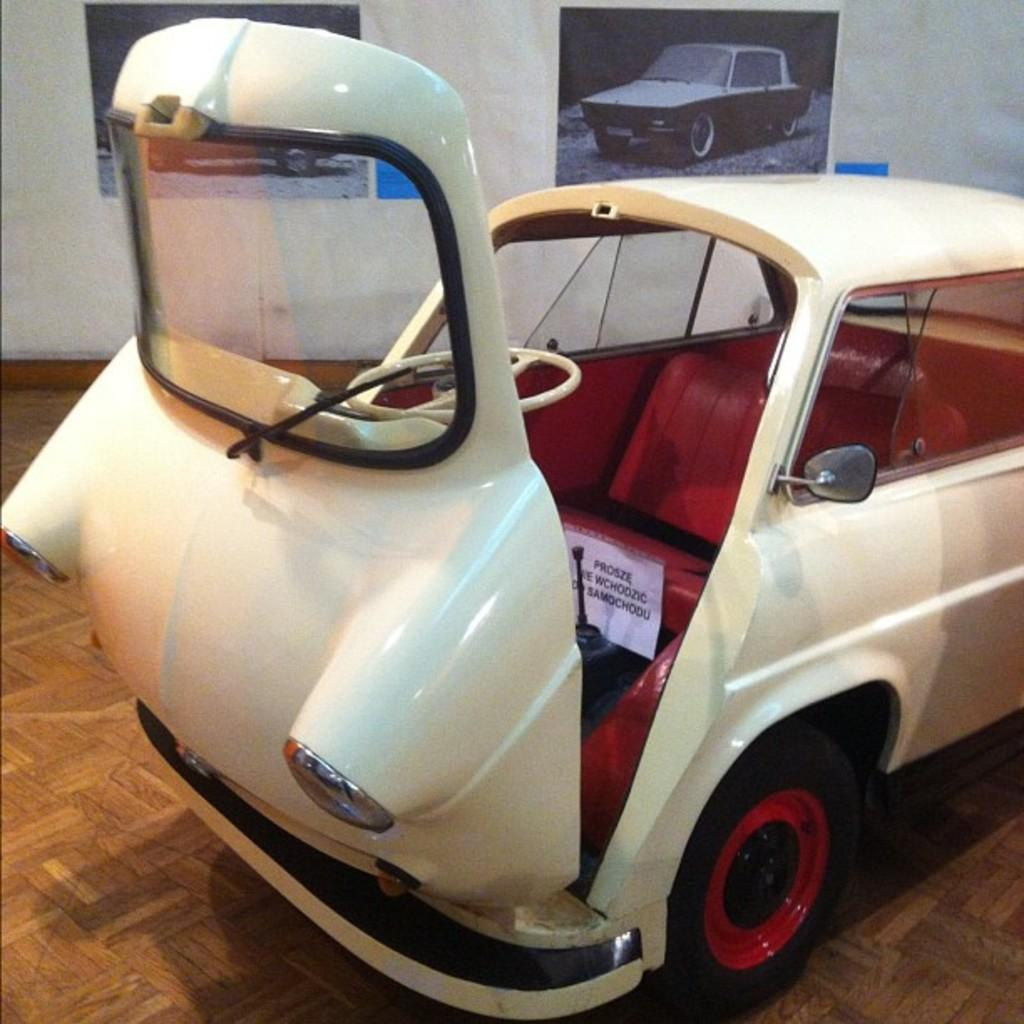What type of vehicle is in the image? There is a white car in the image. What else can be seen on the walls in the image? There are posters with text and images in the image. What is the background of the image made up of? There is a wall visible in the image. How many cherries are on the car in the image? There are no cherries present on the car in the image. Is the person in the image sleeping? There is no person visible in the image, so it cannot be determined if someone is sleeping. 